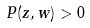Convert formula to latex. <formula><loc_0><loc_0><loc_500><loc_500>P ( z , w ) > 0</formula> 